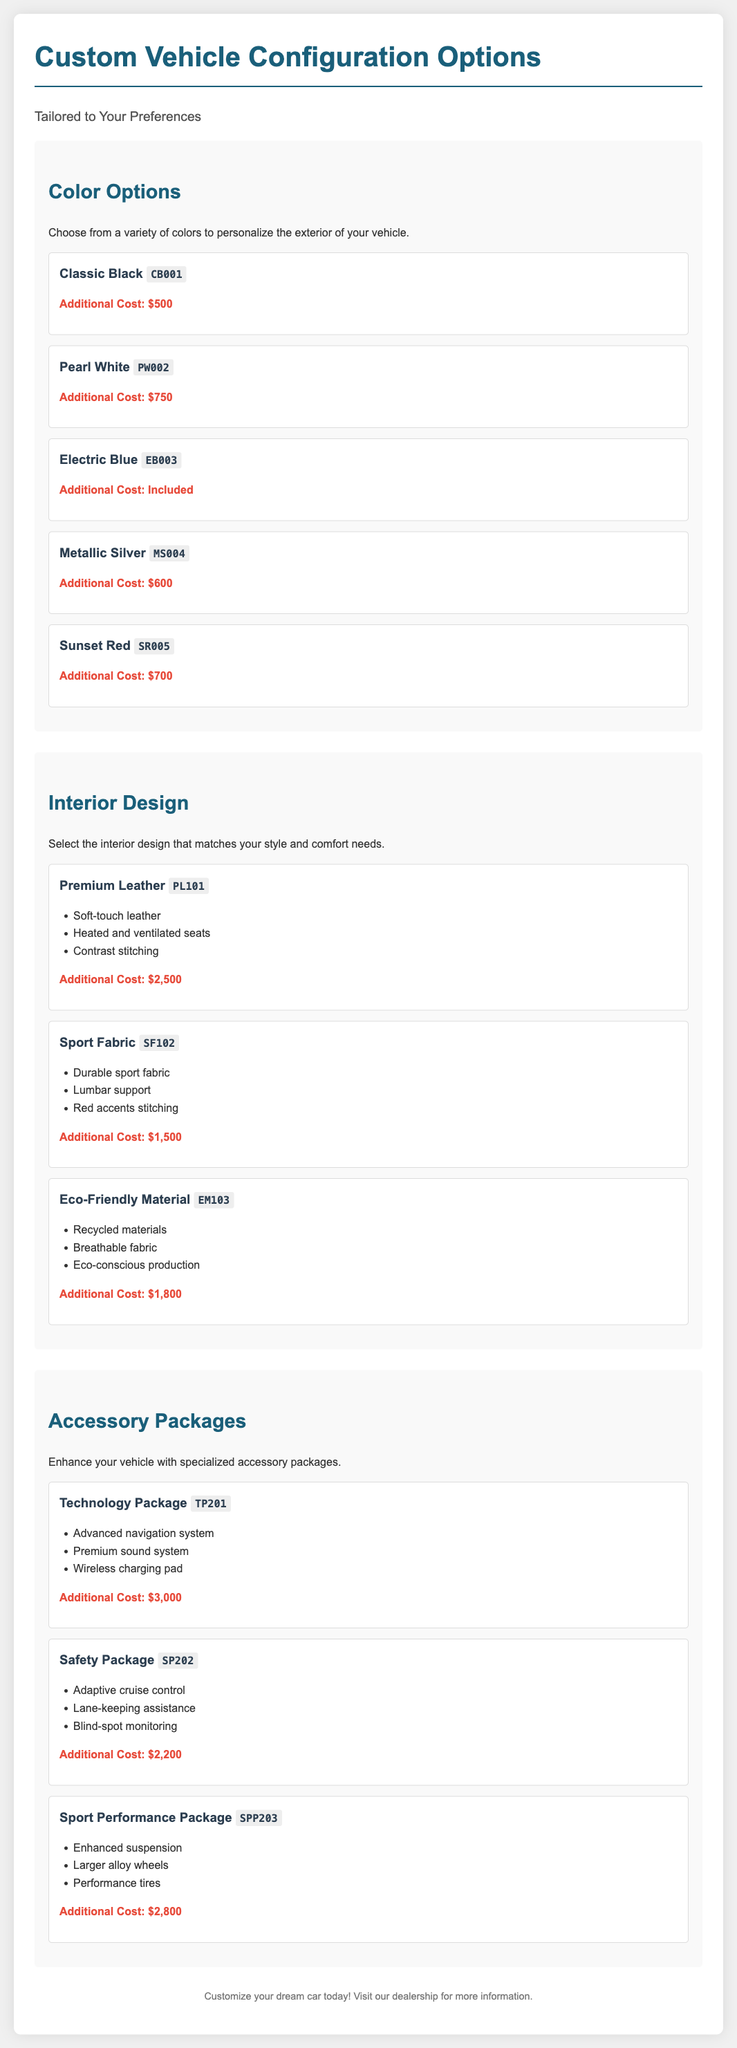What is the additional cost for Classic Black? The additional cost for Classic Black is stated directly in the document as $500.
Answer: $500 How many interior design options are there? There are three interior design options listed in the document: Premium Leather, Sport Fabric, and Eco-Friendly Material.
Answer: Three What color option has no additional cost? The document specifies that Electric Blue has no additional cost.
Answer: Electric Blue What is included in the Technology Package? The Technology Package includes an advanced navigation system, premium sound system, and wireless charging pad as specified in the document.
Answer: Advanced navigation system, premium sound system, wireless charging pad What is the additional cost for the Sport Performance Package? The document mentions the additional cost for the Sport Performance Package as $2,800.
Answer: $2,800 Which interior design option is the most expensive? The Premium Leather option is listed with the highest cost of $2,500.
Answer: Premium Leather How many colors are available in total? The document lists five color options available for customization.
Answer: Five What are the features included in the Safety Package? The Safety Package features adaptive cruise control, lane-keeping assistance, and blind-spot monitoring according to the document.
Answer: Adaptive cruise control, lane-keeping assistance, blind-spot monitoring 